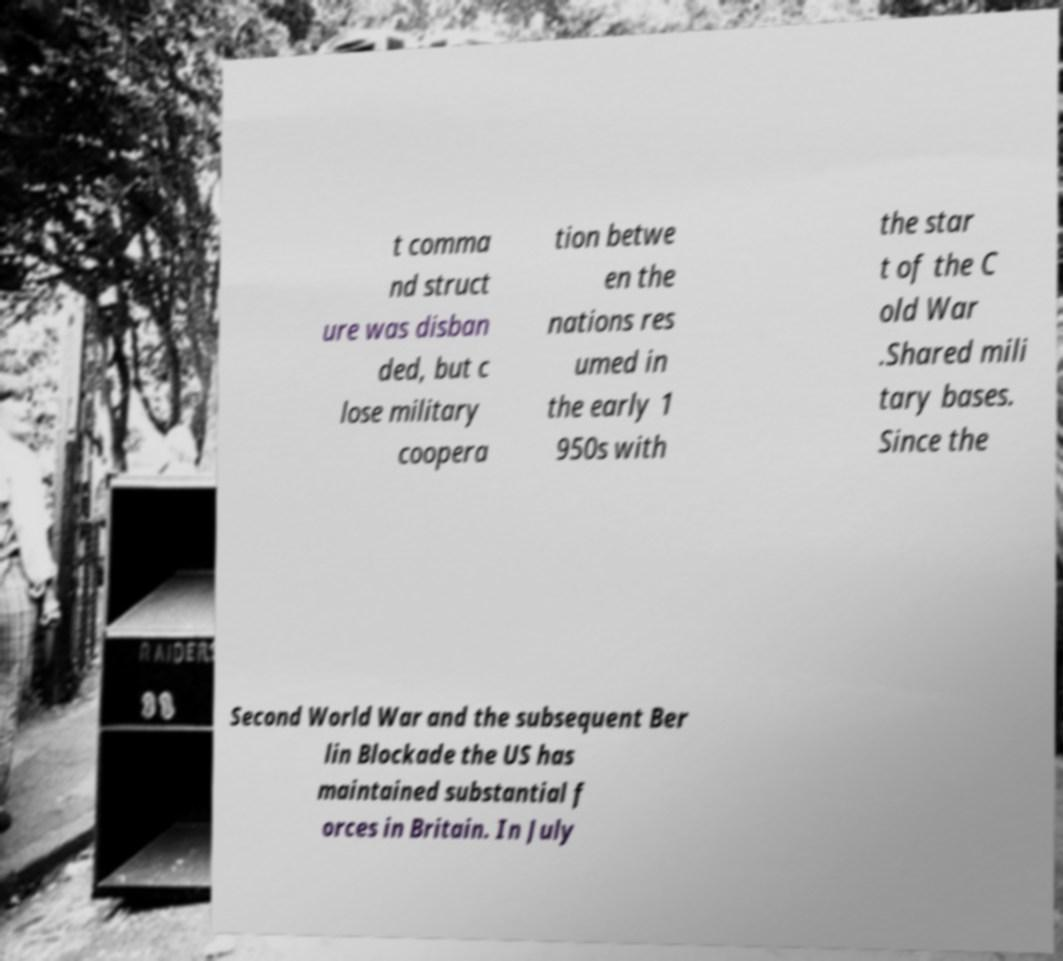Could you extract and type out the text from this image? t comma nd struct ure was disban ded, but c lose military coopera tion betwe en the nations res umed in the early 1 950s with the star t of the C old War .Shared mili tary bases. Since the Second World War and the subsequent Ber lin Blockade the US has maintained substantial f orces in Britain. In July 